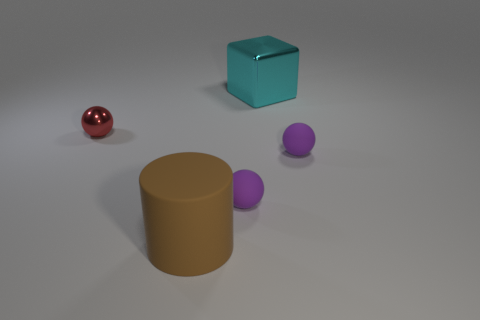How many cyan metal things are there?
Your response must be concise. 1. There is a small sphere that is made of the same material as the big block; what color is it?
Ensure brevity in your answer.  Red. Is the number of big cyan metallic cylinders greater than the number of red shiny balls?
Your answer should be compact. No. There is a rubber object that is both behind the big rubber cylinder and left of the large cyan object; what is its size?
Keep it short and to the point. Small. Are there the same number of metallic blocks in front of the large brown cylinder and tiny purple matte balls?
Provide a short and direct response. No. Does the red object have the same size as the cyan cube?
Your response must be concise. No. There is a sphere that is both on the left side of the cyan thing and right of the tiny red shiny object; what is its color?
Ensure brevity in your answer.  Purple. What material is the cyan block to the right of the metal thing to the left of the brown cylinder made of?
Provide a succinct answer. Metal. There is a big object behind the big brown object; is it the same color as the tiny metal thing?
Ensure brevity in your answer.  No. Are there fewer purple things than small cyan shiny balls?
Your answer should be very brief. No. 